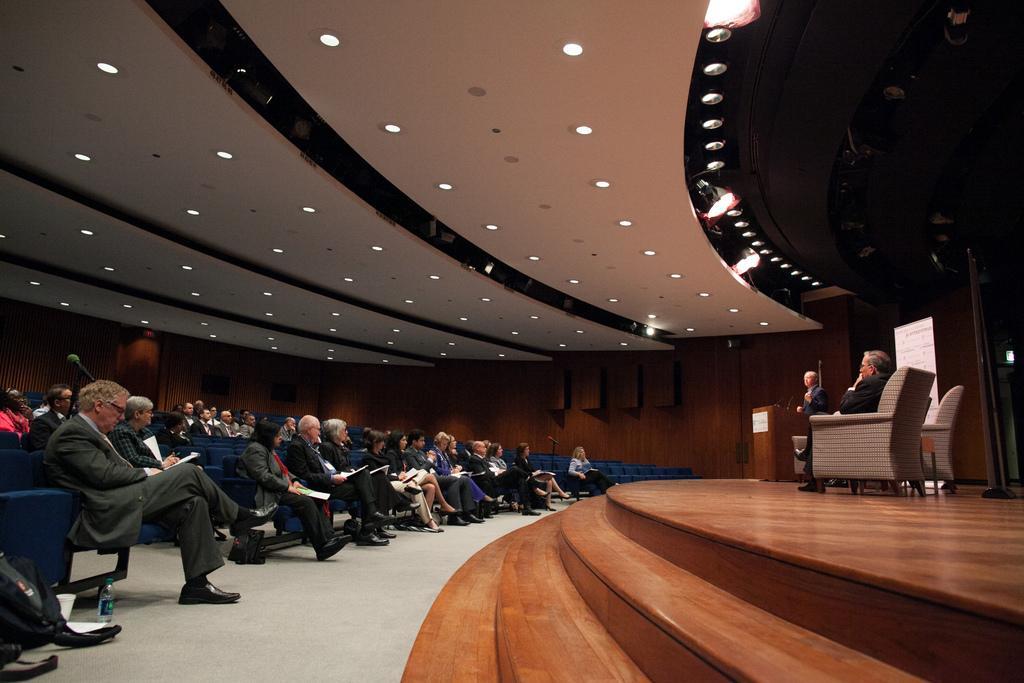Describe this image in one or two sentences. In the picture I can see few persons sitting in chairs and holding few papers in their hands in the left corner and there are two persons in the right corner where one among them is sitting in sofa and the another one is standing in front of them and there are few lights attached to the roof above them. 